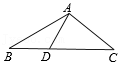First perform reasoning, then finally select the question from the choices in the following format: Answer: xxx.
Question: If in triangle ABC, the lengths of AB and AC are equal, and D lies on the perpendicular bisector of AB, and angle ADC is 80 degrees, what is the measure of angle C?
Choices:
A: 60°
B: 50°
C: 40°
D: 30° Because D is a point on the perpendicular bisector of AB, we have AD = BD. Therefore, angle B is equal to angle BAD. Given that angle ADC is 80°, we have angle B = angle BAD = 40°. Since AB = AC, we also have angle C = angle B = 40°. Hence, the answer is C.
Answer:C 